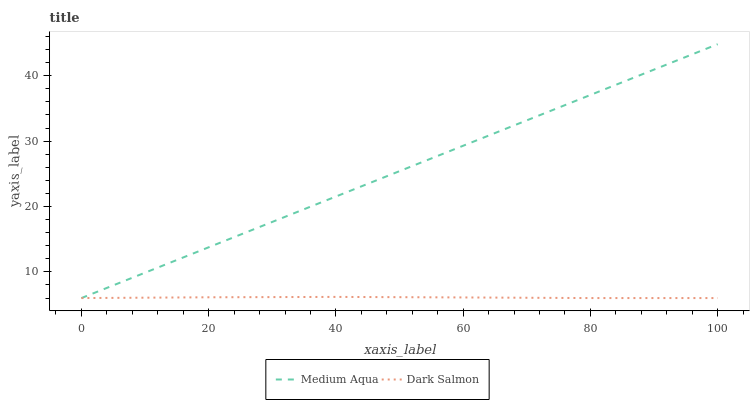Does Dark Salmon have the minimum area under the curve?
Answer yes or no. Yes. Does Medium Aqua have the maximum area under the curve?
Answer yes or no. Yes. Does Dark Salmon have the maximum area under the curve?
Answer yes or no. No. Is Medium Aqua the smoothest?
Answer yes or no. Yes. Is Dark Salmon the roughest?
Answer yes or no. Yes. Is Dark Salmon the smoothest?
Answer yes or no. No. Does Medium Aqua have the lowest value?
Answer yes or no. Yes. Does Medium Aqua have the highest value?
Answer yes or no. Yes. Does Dark Salmon have the highest value?
Answer yes or no. No. Does Medium Aqua intersect Dark Salmon?
Answer yes or no. Yes. Is Medium Aqua less than Dark Salmon?
Answer yes or no. No. Is Medium Aqua greater than Dark Salmon?
Answer yes or no. No. 